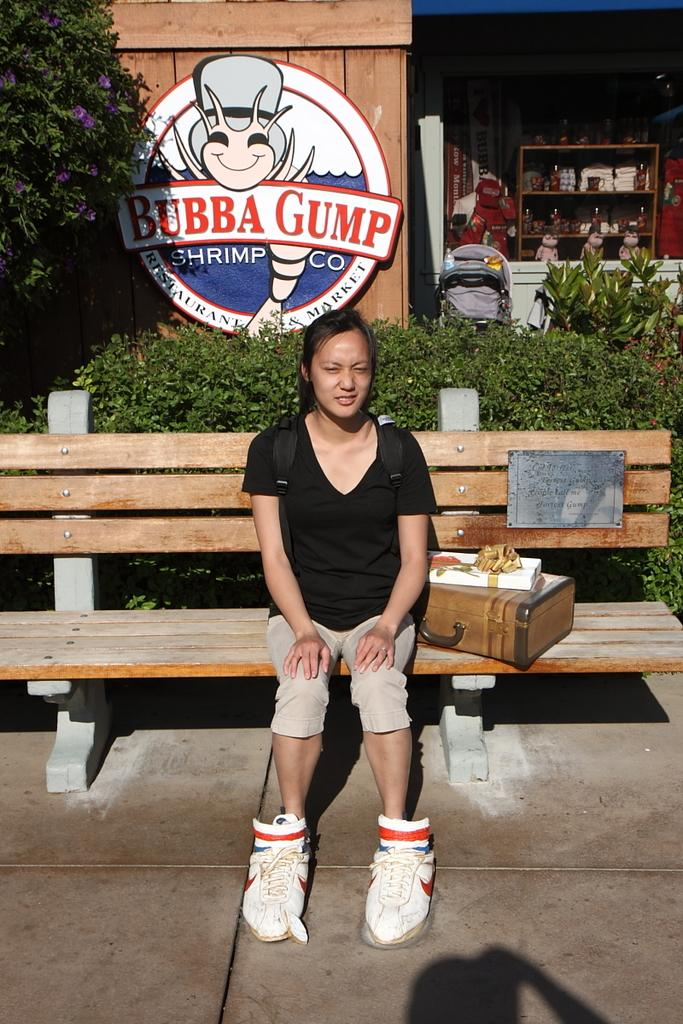What type of establishment is depicted in the image? There is a store in the image. What can be seen in the background of the image? There are trees and plants in the image. Is there any signage or identification for the store? Yes, there is a name board in the image. What is the woman on the bench doing? The woman is sitting on a bench in the image. What object is beside the woman on the bench? There is a box beside the woman on the bench. What type of trail can be seen leading up to the store in the image? There is no trail visible in the image; it only shows a store, trees, plants, a name board, a woman sitting on a bench, and a box beside her. 